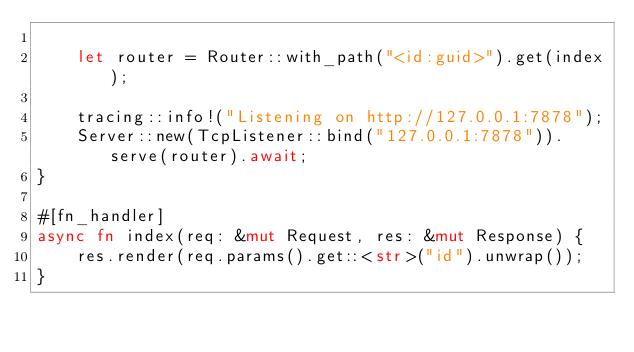<code> <loc_0><loc_0><loc_500><loc_500><_Rust_>
    let router = Router::with_path("<id:guid>").get(index);

    tracing::info!("Listening on http://127.0.0.1:7878");
    Server::new(TcpListener::bind("127.0.0.1:7878")).serve(router).await;
}

#[fn_handler]
async fn index(req: &mut Request, res: &mut Response) {
    res.render(req.params().get::<str>("id").unwrap());
}
</code> 